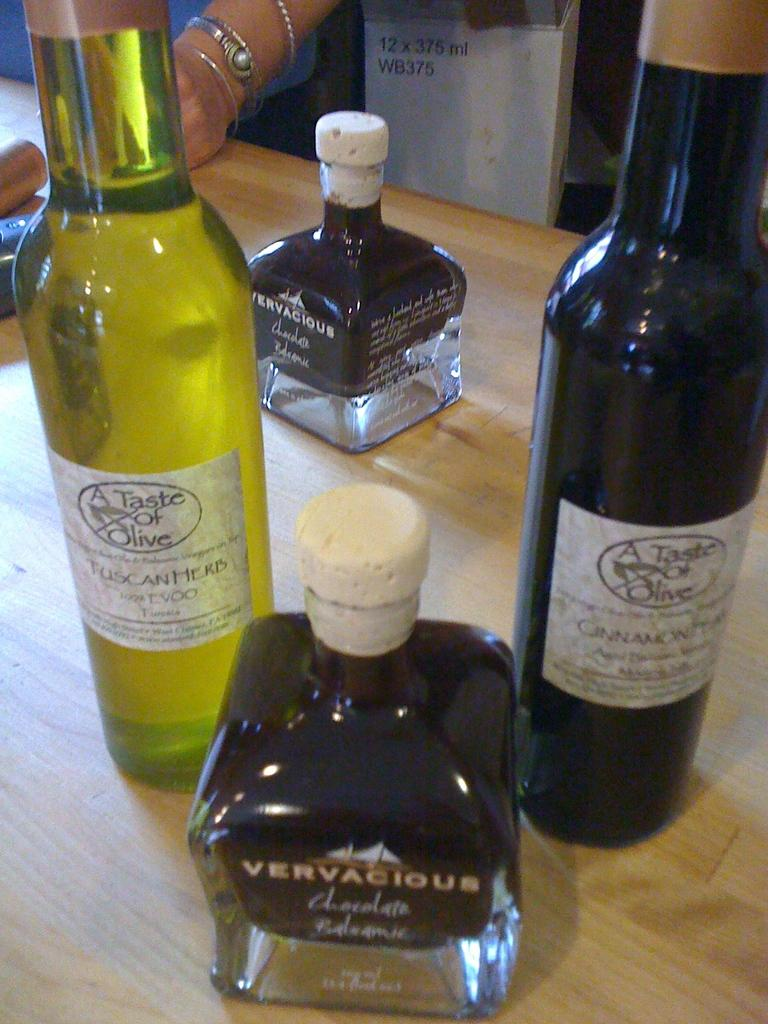<image>
Write a terse but informative summary of the picture. Various brands of olive oil including a tuscan herb variety. 